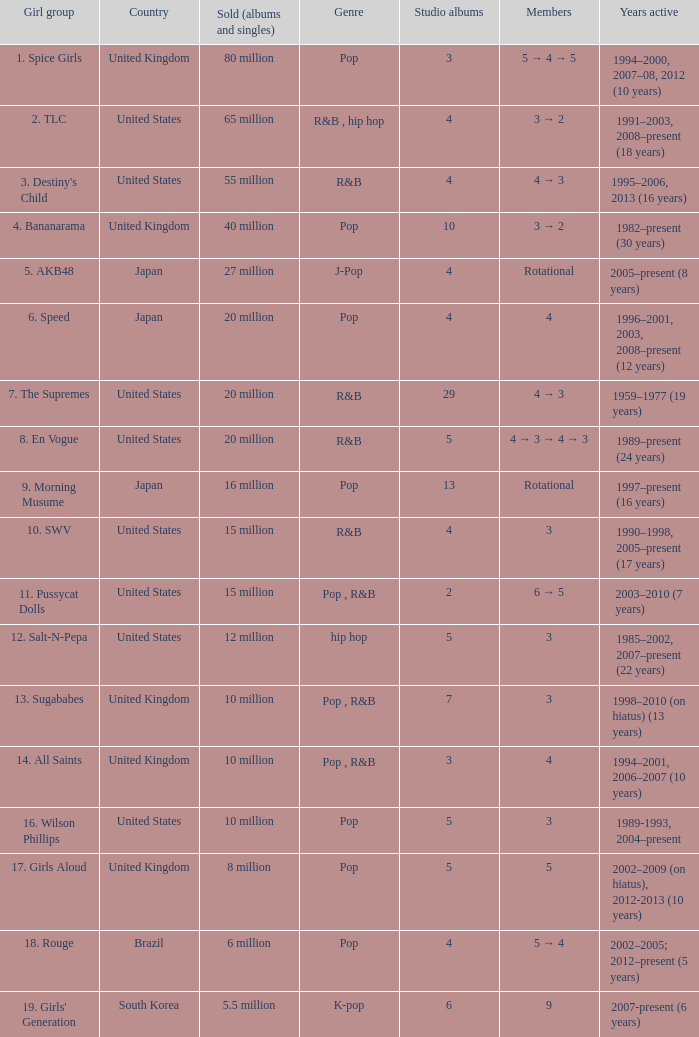Which ensemble produced 29 studio records? 7. The Supremes. 